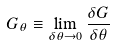<formula> <loc_0><loc_0><loc_500><loc_500>G _ { \theta } \equiv \lim _ { \delta \theta \rightarrow 0 } \frac { \delta G } { \delta \theta }</formula> 